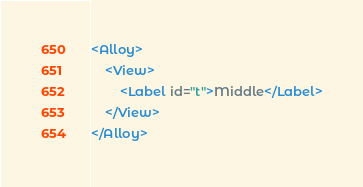Convert code to text. <code><loc_0><loc_0><loc_500><loc_500><_XML_><Alloy>
	<View>
		<Label id="t">Middle</Label>
	</View>
</Alloy>
</code> 